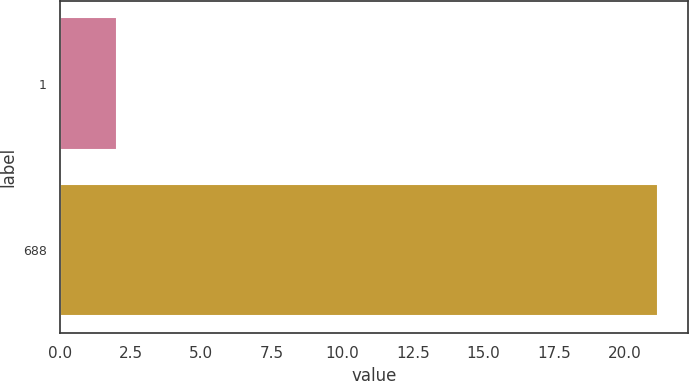Convert chart. <chart><loc_0><loc_0><loc_500><loc_500><bar_chart><fcel>1<fcel>688<nl><fcel>2<fcel>21.2<nl></chart> 